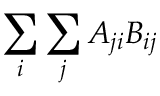<formula> <loc_0><loc_0><loc_500><loc_500>\sum _ { i } \sum _ { j } A _ { j i } B _ { i j }</formula> 